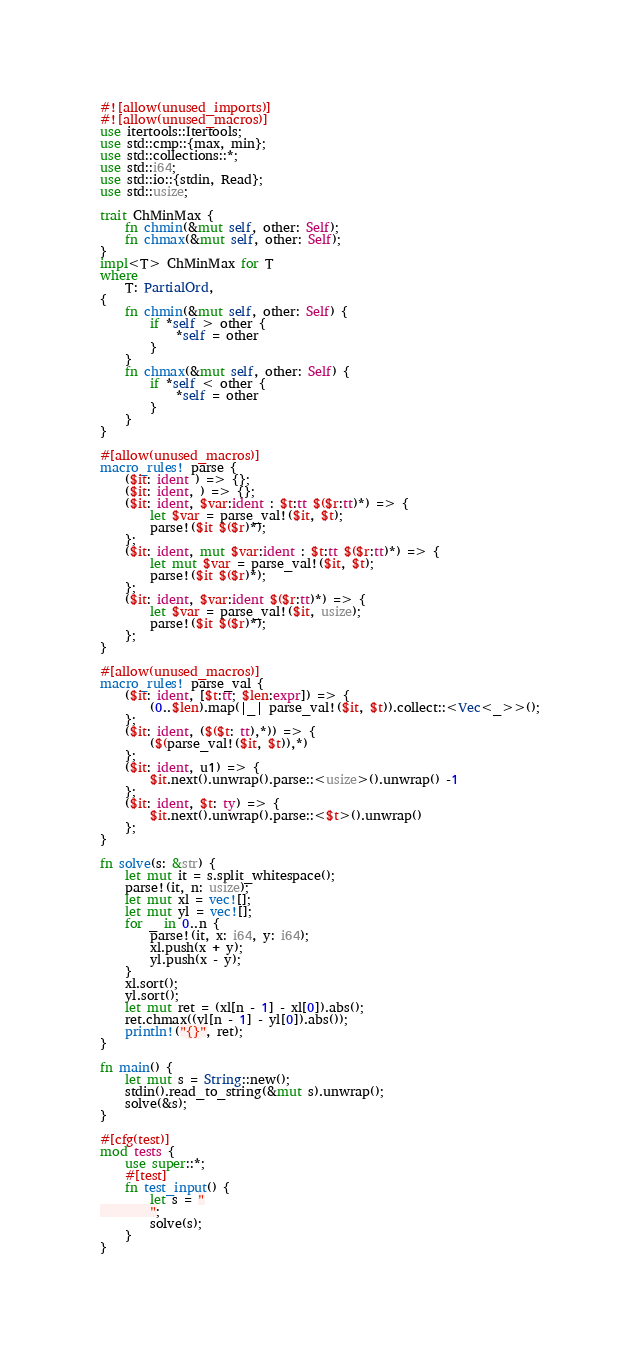<code> <loc_0><loc_0><loc_500><loc_500><_Rust_>#![allow(unused_imports)]
#![allow(unused_macros)]
use itertools::Itertools;
use std::cmp::{max, min};
use std::collections::*;
use std::i64;
use std::io::{stdin, Read};
use std::usize;

trait ChMinMax {
    fn chmin(&mut self, other: Self);
    fn chmax(&mut self, other: Self);
}
impl<T> ChMinMax for T
where
    T: PartialOrd,
{
    fn chmin(&mut self, other: Self) {
        if *self > other {
            *self = other
        }
    }
    fn chmax(&mut self, other: Self) {
        if *self < other {
            *self = other
        }
    }
}

#[allow(unused_macros)]
macro_rules! parse {
    ($it: ident ) => {};
    ($it: ident, ) => {};
    ($it: ident, $var:ident : $t:tt $($r:tt)*) => {
        let $var = parse_val!($it, $t);
        parse!($it $($r)*);
    };
    ($it: ident, mut $var:ident : $t:tt $($r:tt)*) => {
        let mut $var = parse_val!($it, $t);
        parse!($it $($r)*);
    };
    ($it: ident, $var:ident $($r:tt)*) => {
        let $var = parse_val!($it, usize);
        parse!($it $($r)*);
    };
}

#[allow(unused_macros)]
macro_rules! parse_val {
    ($it: ident, [$t:tt; $len:expr]) => {
        (0..$len).map(|_| parse_val!($it, $t)).collect::<Vec<_>>();
    };
    ($it: ident, ($($t: tt),*)) => {
        ($(parse_val!($it, $t)),*)
    };
    ($it: ident, u1) => {
        $it.next().unwrap().parse::<usize>().unwrap() -1
    };
    ($it: ident, $t: ty) => {
        $it.next().unwrap().parse::<$t>().unwrap()
    };
}

fn solve(s: &str) {
    let mut it = s.split_whitespace();
    parse!(it, n: usize);
    let mut xl = vec![];
    let mut yl = vec![];
    for _ in 0..n {
        parse!(it, x: i64, y: i64);
        xl.push(x + y);
        yl.push(x - y);
    }
    xl.sort();
    yl.sort();
    let mut ret = (xl[n - 1] - xl[0]).abs();
    ret.chmax((yl[n - 1] - yl[0]).abs());
    println!("{}", ret);
}

fn main() {
    let mut s = String::new();
    stdin().read_to_string(&mut s).unwrap();
    solve(&s);
}

#[cfg(test)]
mod tests {
    use super::*;
    #[test]
    fn test_input() {
        let s = "
        ";
        solve(s);
    }
}
</code> 